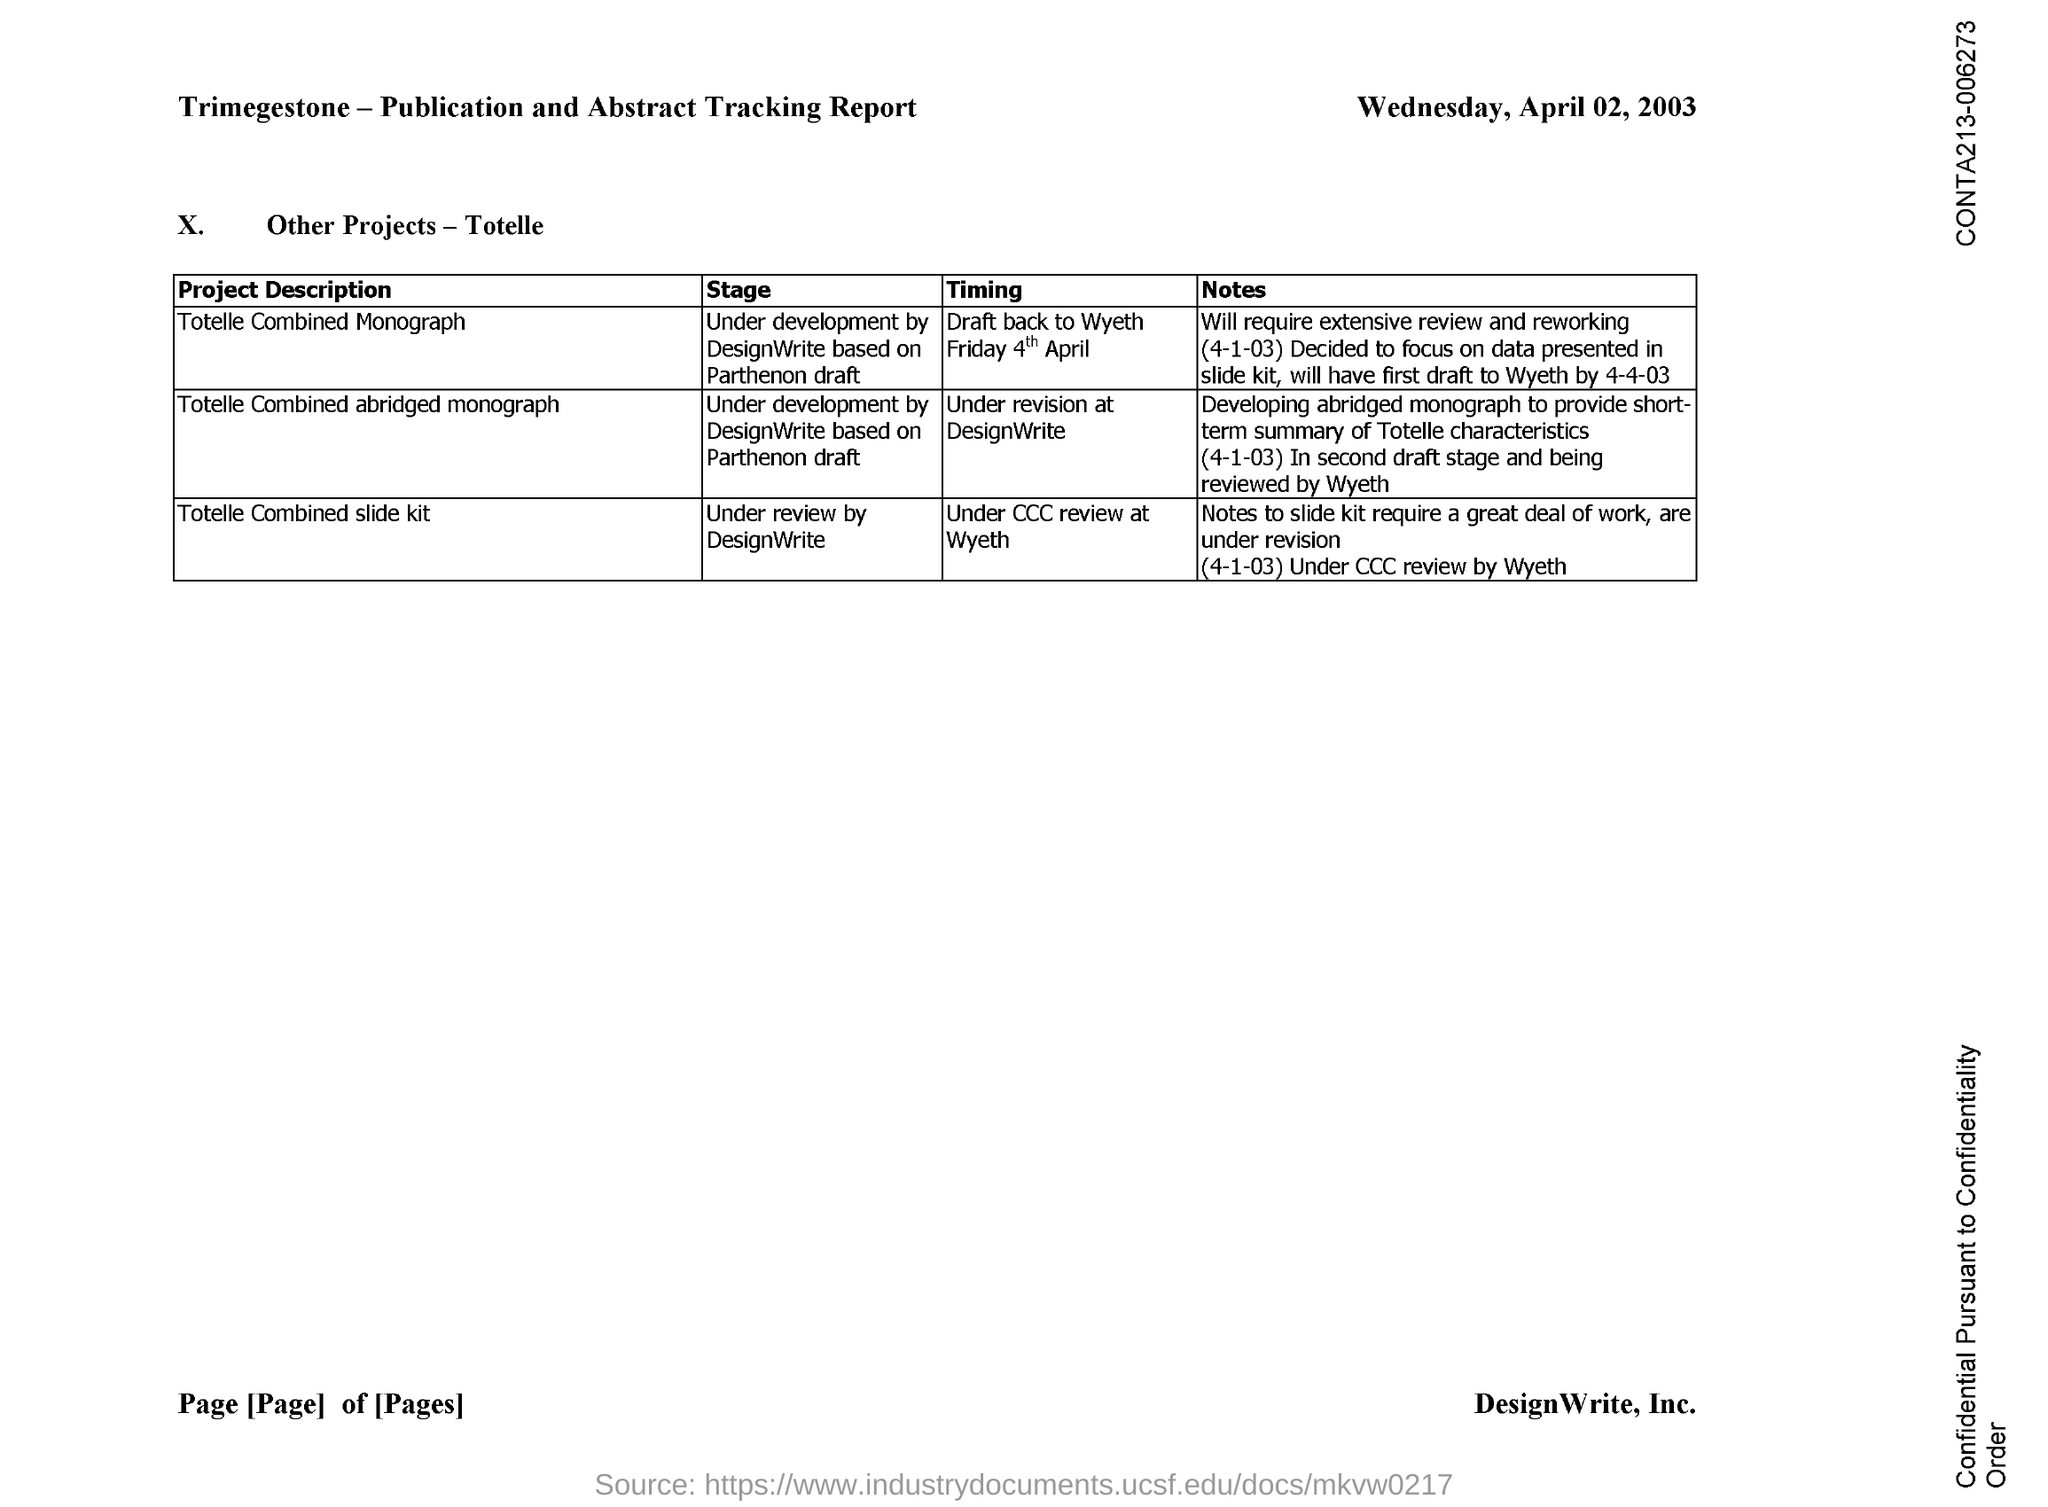Mention a couple of crucial points in this snapshot. The "Totelle Combined Monograph" project is currently under development by DesignWrite, based on the Parthenon draft. The "Totelle Combined slide kit" project is currently under review by DesignWrite. 